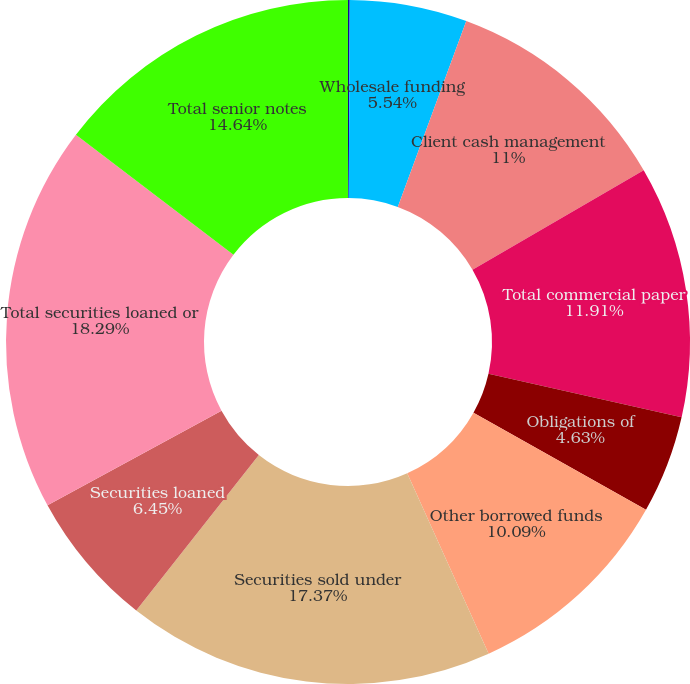Convert chart to OTSL. <chart><loc_0><loc_0><loc_500><loc_500><pie_chart><fcel>(in millions)<fcel>Wholesale funding<fcel>Client cash management<fcel>Total commercial paper<fcel>Obligations of<fcel>Other borrowed funds<fcel>Securities sold under<fcel>Securities loaned<fcel>Total securities loaned or<fcel>Total senior notes<nl><fcel>0.08%<fcel>5.54%<fcel>11.0%<fcel>11.91%<fcel>4.63%<fcel>10.09%<fcel>17.37%<fcel>6.45%<fcel>18.28%<fcel>14.64%<nl></chart> 